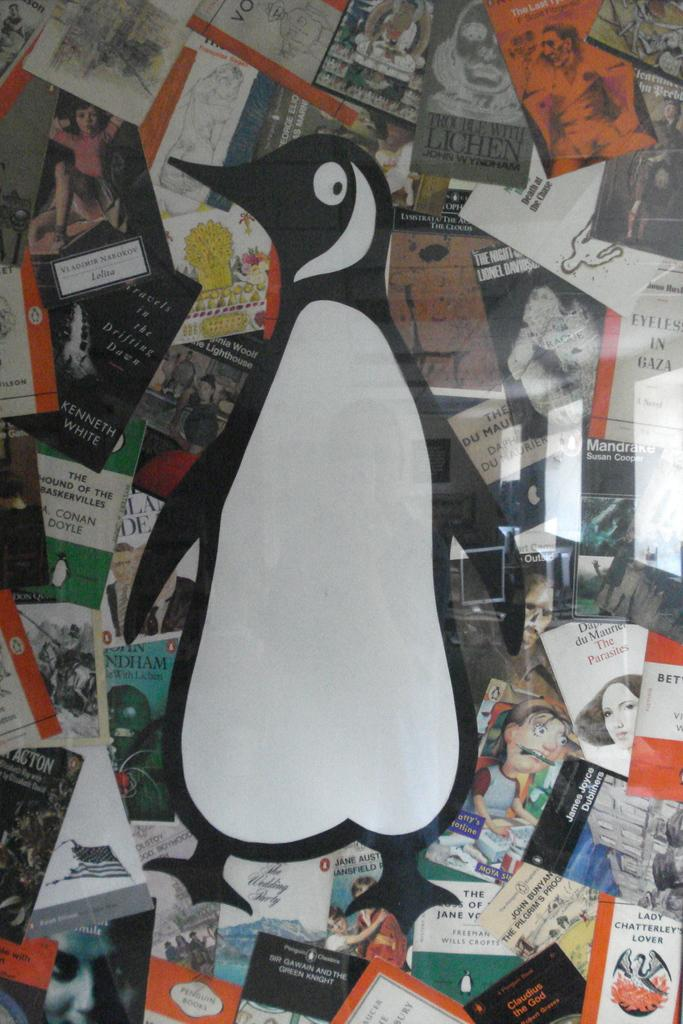What type of animal is in the image? There is a penguin in the image. What color is the penguin? The penguin is in black and white color. What can be seen in the background of the image? There are papers attached to an object in the background of the image. What type of creature is playing on the scale in the image? There is no scale or creature playing on it in the image. The image only features a penguin and papers attached to an object in the background. 